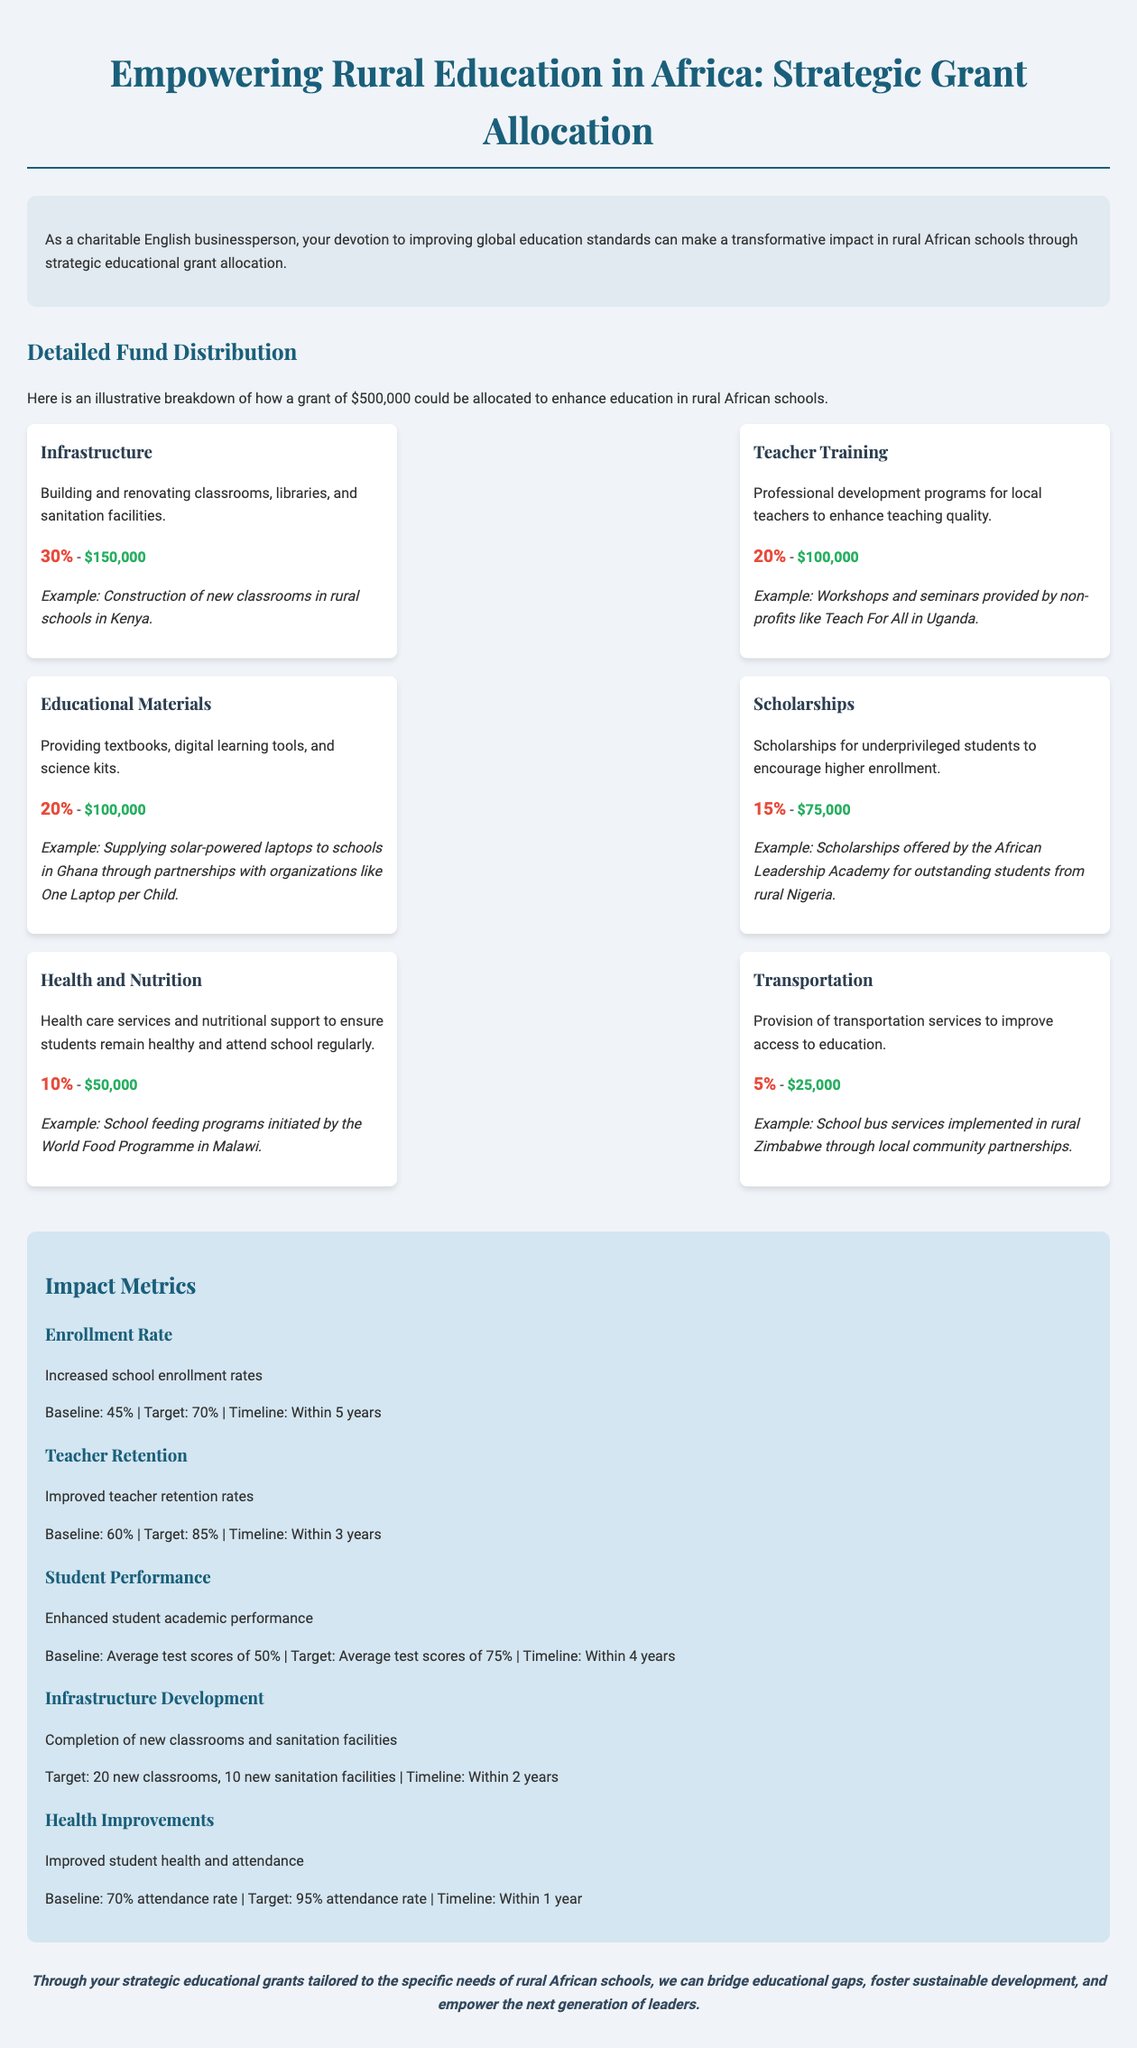What is the total grant amount? The total grant amount discussed in the document is $500,000.
Answer: $500,000 How much is allocated to infrastructure? The document specifies that 30% of the grant is allocated to infrastructure, which amounts to $150,000.
Answer: $150,000 What is the target enrollment rate? The target enrollment rate outlined in the impact metrics is 70%.
Answer: 70% Who provides the workshops for teacher training? The document mentions that non-profits like Teach For All provide workshops for teacher training.
Answer: Teach For All What is the baseline attendance rate? According to the impact metrics, the baseline attendance rate is 70%.
Answer: 70% What percentage of the fund is allocated to transportation? The allocation for transportation in the document is 5%.
Answer: 5% What is the timeline for improved teacher retention? The timeline to achieve improved teacher retention is stated to be within 3 years.
Answer: Within 3 years How many new classrooms are targeted for completion? The document targets the completion of 20 new classrooms.
Answer: 20 new classrooms What is the health improvement target attendance rate? The targeted attendance rate for health improvements is 95%.
Answer: 95% 